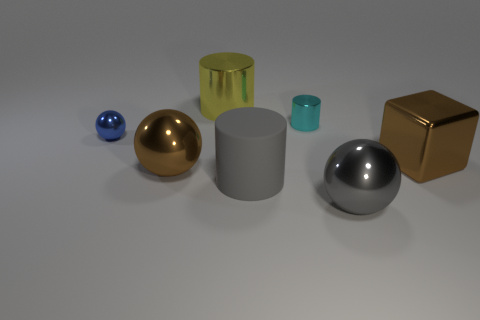How many other things are the same size as the yellow object?
Ensure brevity in your answer.  4. How many small blue metallic objects are behind the big gray ball?
Offer a very short reply. 1. The cube has what size?
Provide a short and direct response. Large. Is the brown thing that is on the right side of the gray metal object made of the same material as the sphere in front of the large matte cylinder?
Your response must be concise. Yes. Are there any big metallic spheres of the same color as the large rubber cylinder?
Keep it short and to the point. Yes. There is a metallic cube that is the same size as the gray cylinder; what color is it?
Your response must be concise. Brown. Is the color of the small thing on the right side of the brown shiny ball the same as the large rubber cylinder?
Make the answer very short. No. Is there another gray ball that has the same material as the large gray sphere?
Make the answer very short. No. What shape is the large metallic thing that is the same color as the big metallic cube?
Make the answer very short. Sphere. Are there fewer gray things that are right of the large rubber cylinder than tiny gray cubes?
Give a very brief answer. No. 